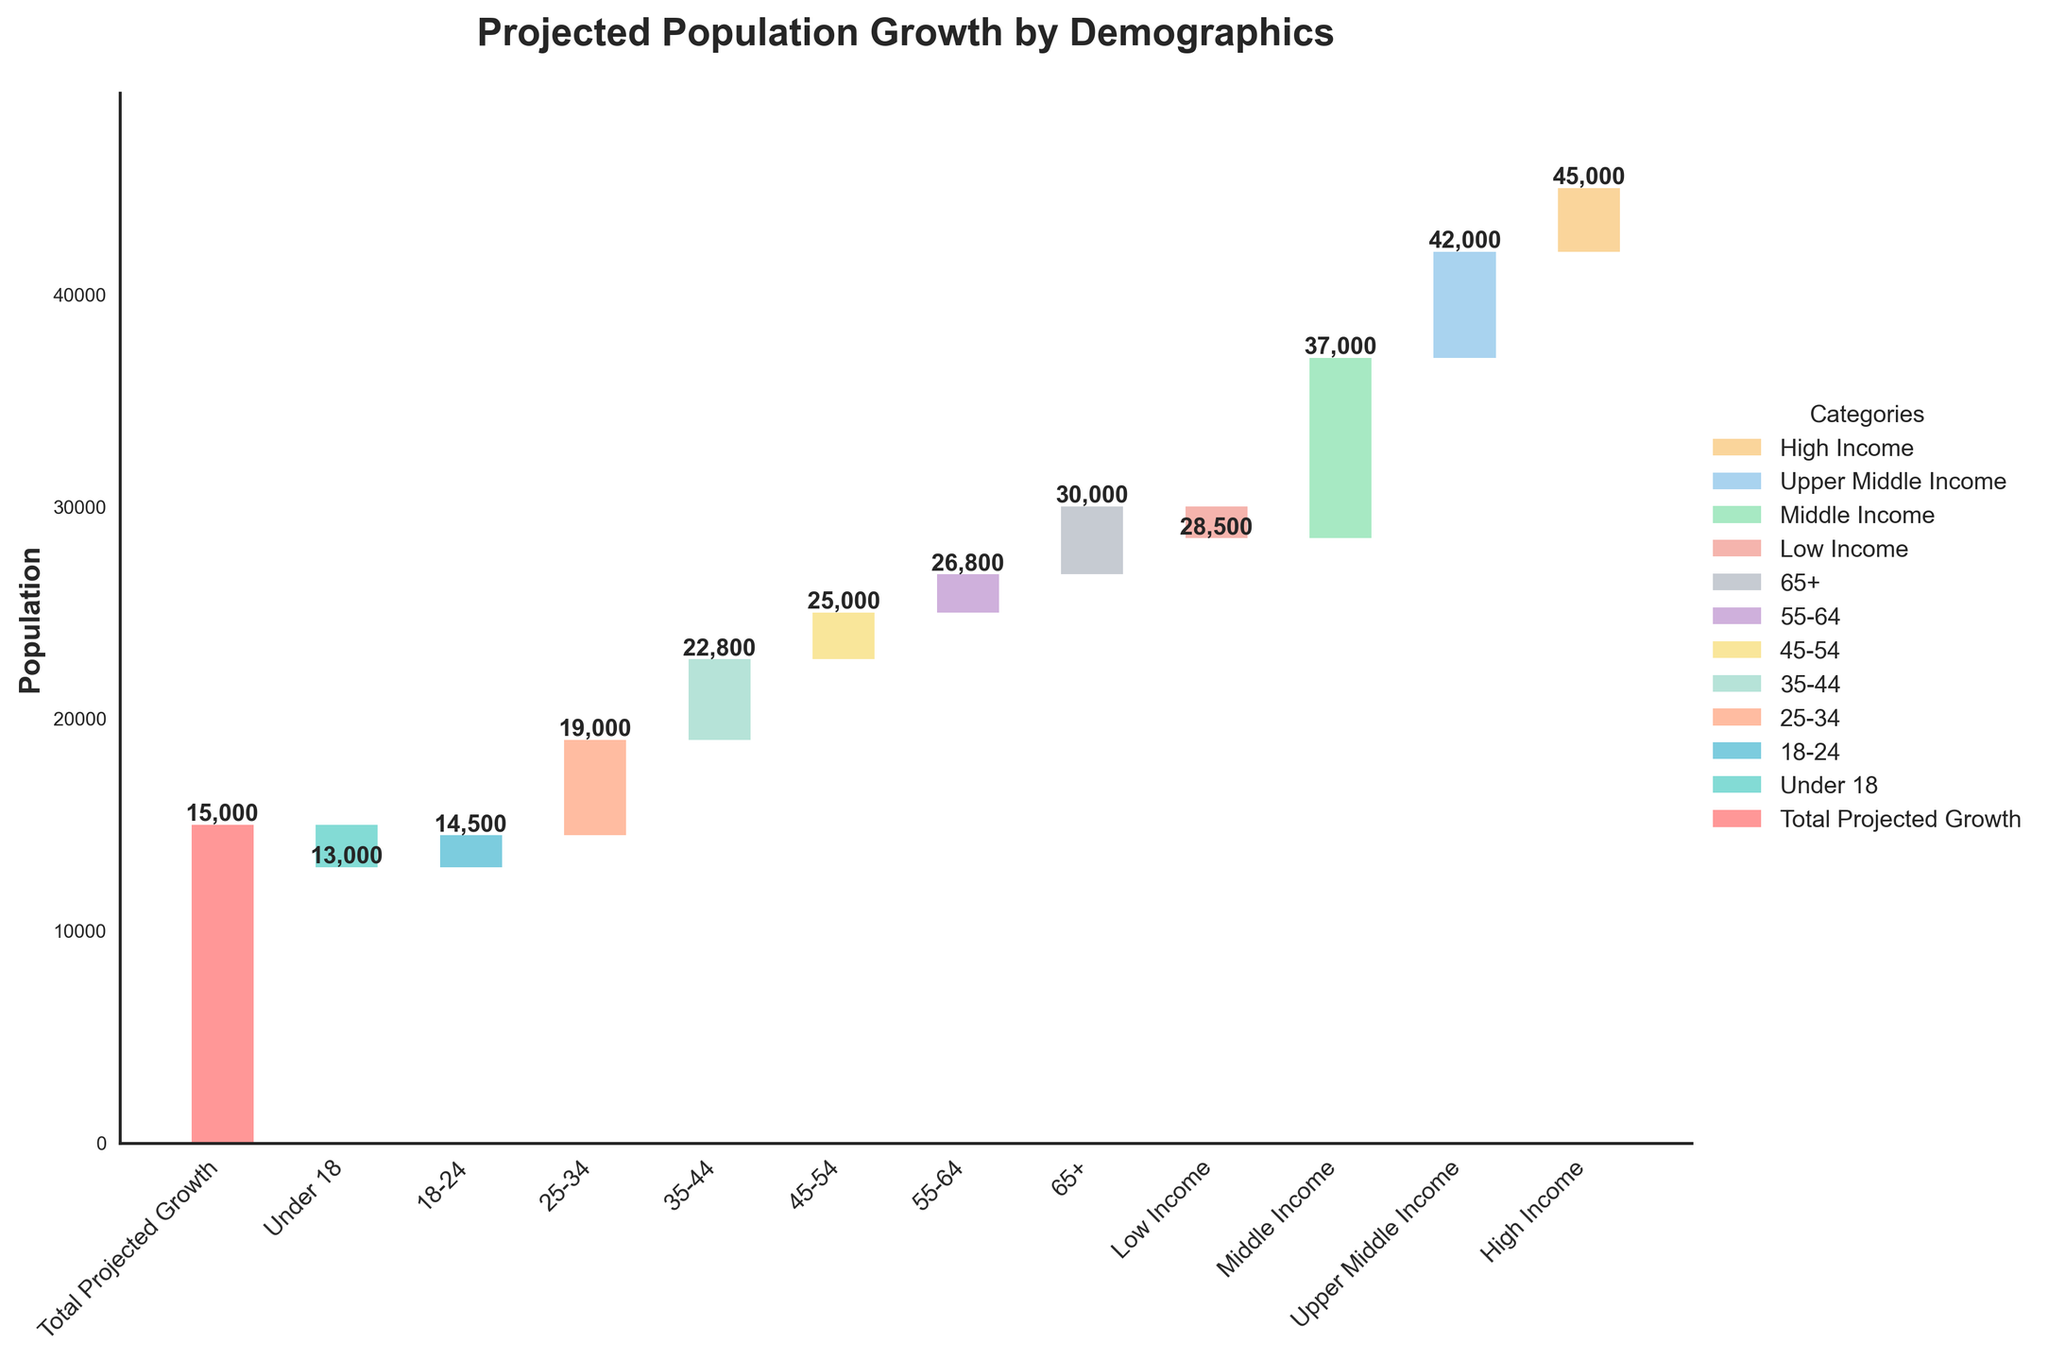What is the total projected population growth over the next decade? The total projected growth is shown in the first bar, labeled "Total Projected Growth." The value for this category is 15,000, clearly marked in the figure.
Answer: 15,000 How much is the projected decrease in population for the 'Under 18' age group? The figure shows a negative value for the 'Under 18' age group, indicating a decrease. The specific value is -2,000, which implies a population decrease of 2,000 for this age group.
Answer: 2,000 Which age group has the highest projected population growth? Looking at the individual categories for age groups, the '25-34' age group has the highest positive value of 4,500.
Answer: 25-34 What is the cumulative population growth by the end of the '35-44' age group? The cumulative value is obtained by summing up the values of the 'Under 18', '18-24', '25-34', and '35-44' age groups. This is (-2,000) + 1,500 + 4,500 + 3,800 = 7,800.
Answer: 7,800 How does the growth in high-income population compare to the decrease in low-income population? The growth in the high-income category is 3,000 and the decrease in the low-income category is -1,500. Comparing these values, the high-income growth (3,000) is double the low-income decrease (1,500).
Answer: 3,000 vs 1,500 What is the cumulative impact on population from all income levels? To find the cumulative impact, we sum the values of all income categories: -1,500 (Low Income) + 8,500 (Middle Income) + 5,000 (Upper Middle Income) + 3,000 (High Income) = 15,000.
Answer: 15,000 By how much does the '45-54' age group outgrow the '55-64' age group? The growth for the '45-54' age group is 2,200, and for the '55-64' age group is 1,800. The difference between these groups is 2,200 - 1,800 = 400.
Answer: 400 What is the total contribution of all groups aged 35 and above to the projected population growth? Summing the values for the '35-44', '45-54', '55-64', and '65+' age groups: 3,800 + 2,200 + 1,800 + 3,200 = 11,000.
Answer: 11,000 